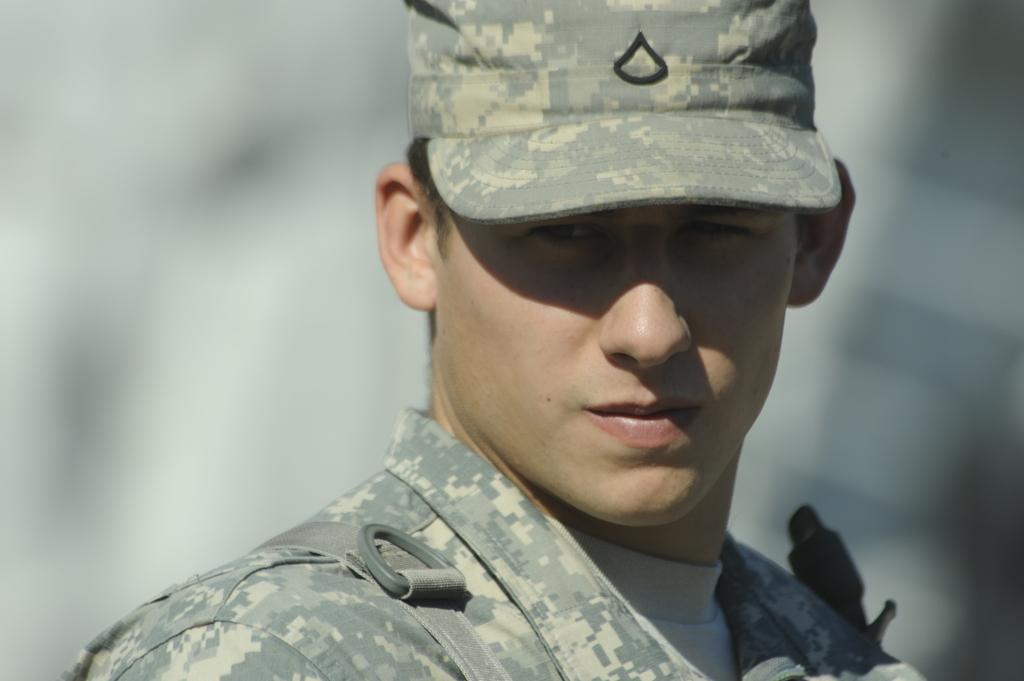Who is present in the image? There is a man in the image. What is the man wearing on his head? The man is wearing a cap. Can you describe the background of the image? The background of the image is blurred. What date is circled on the calendar in the image? There is no calendar present in the image. 